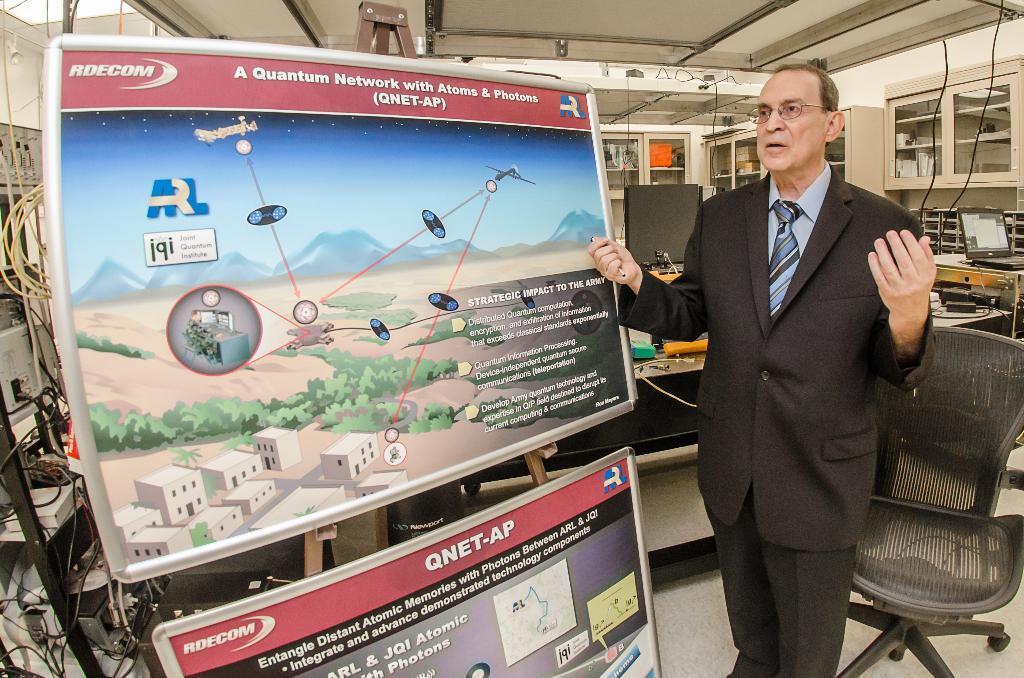Can you describe this image briefly? This image is clicked in a room. This room consists of two boards, a person, system, laptop, cupboards, wires, chair. The person is standing in the middle and he is wearing black colour blazer. The chair is a black color and there are wires on the left side. 